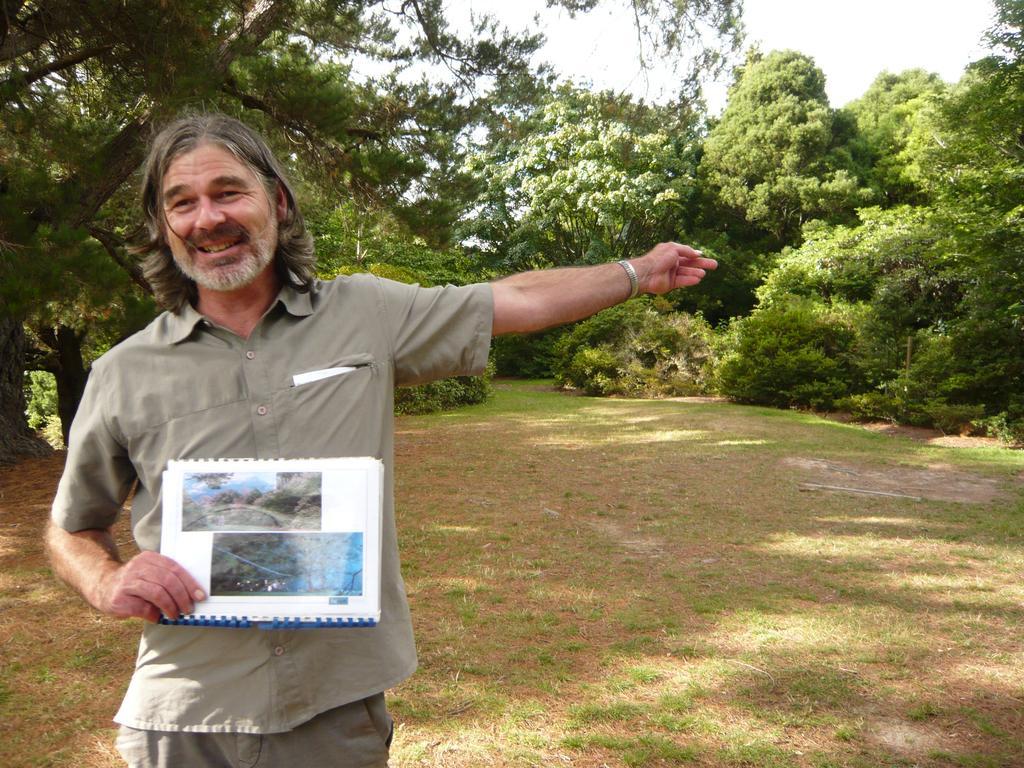How would you summarize this image in a sentence or two? In this image on the left side there is one person standing and he is holding some book, at the bottom there is grass and sand and in the background there are some trees. 